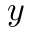Convert formula to latex. <formula><loc_0><loc_0><loc_500><loc_500>y</formula> 